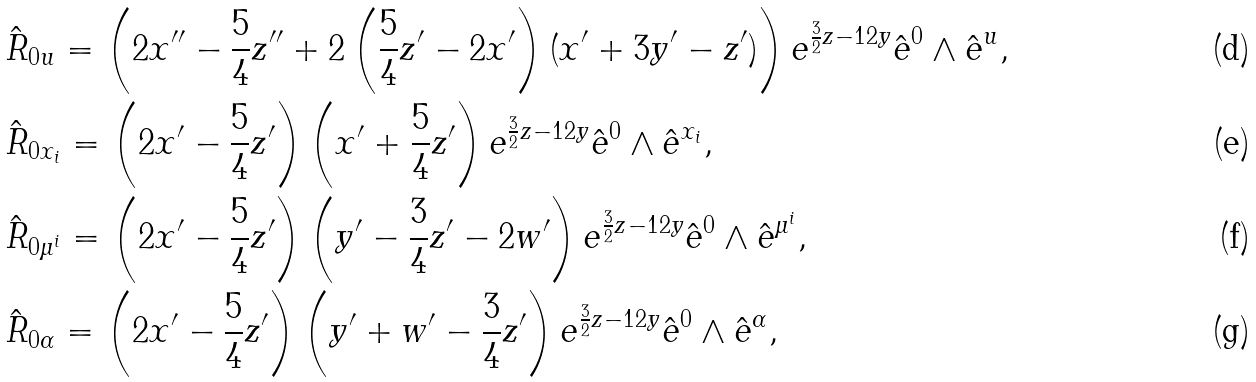<formula> <loc_0><loc_0><loc_500><loc_500>& \hat { R } _ { 0 u } = \left ( 2 x ^ { \prime \prime } - \frac { 5 } { 4 } z ^ { \prime \prime } + 2 \left ( \frac { 5 } { 4 } z ^ { \prime } - 2 x ^ { \prime } \right ) ( x ^ { \prime } + 3 y ^ { \prime } - z ^ { \prime } ) \right ) e ^ { \frac { 3 } { 2 } z - 1 2 y } \hat { e } ^ { 0 } \wedge \hat { e } ^ { u } , \\ & \hat { R } _ { 0 x _ { i } } = \left ( 2 x ^ { \prime } - \frac { 5 } { 4 } z ^ { \prime } \right ) \left ( x ^ { \prime } + \frac { 5 } { 4 } z ^ { \prime } \right ) e ^ { \frac { 3 } { 2 } z - 1 2 y } \hat { e } ^ { 0 } \wedge \hat { e } ^ { x _ { i } } , \\ & \hat { R } _ { 0 \mu ^ { i } } = \left ( 2 x ^ { \prime } - \frac { 5 } { 4 } z ^ { \prime } \right ) \left ( y ^ { \prime } - \frac { 3 } { 4 } z ^ { \prime } - 2 w ^ { \prime } \right ) e ^ { \frac { 3 } { 2 } z - 1 2 y } \hat { e } ^ { 0 } \wedge \hat { e } ^ { \mu ^ { i } } , \\ & \hat { R } _ { 0 \alpha } = \left ( 2 x ^ { \prime } - \frac { 5 } { 4 } z ^ { \prime } \right ) \left ( y ^ { \prime } + w ^ { \prime } - \frac { 3 } { 4 } z ^ { \prime } \right ) e ^ { \frac { 3 } { 2 } z - 1 2 y } \hat { e } ^ { 0 } \wedge \hat { e } ^ { \alpha } ,</formula> 